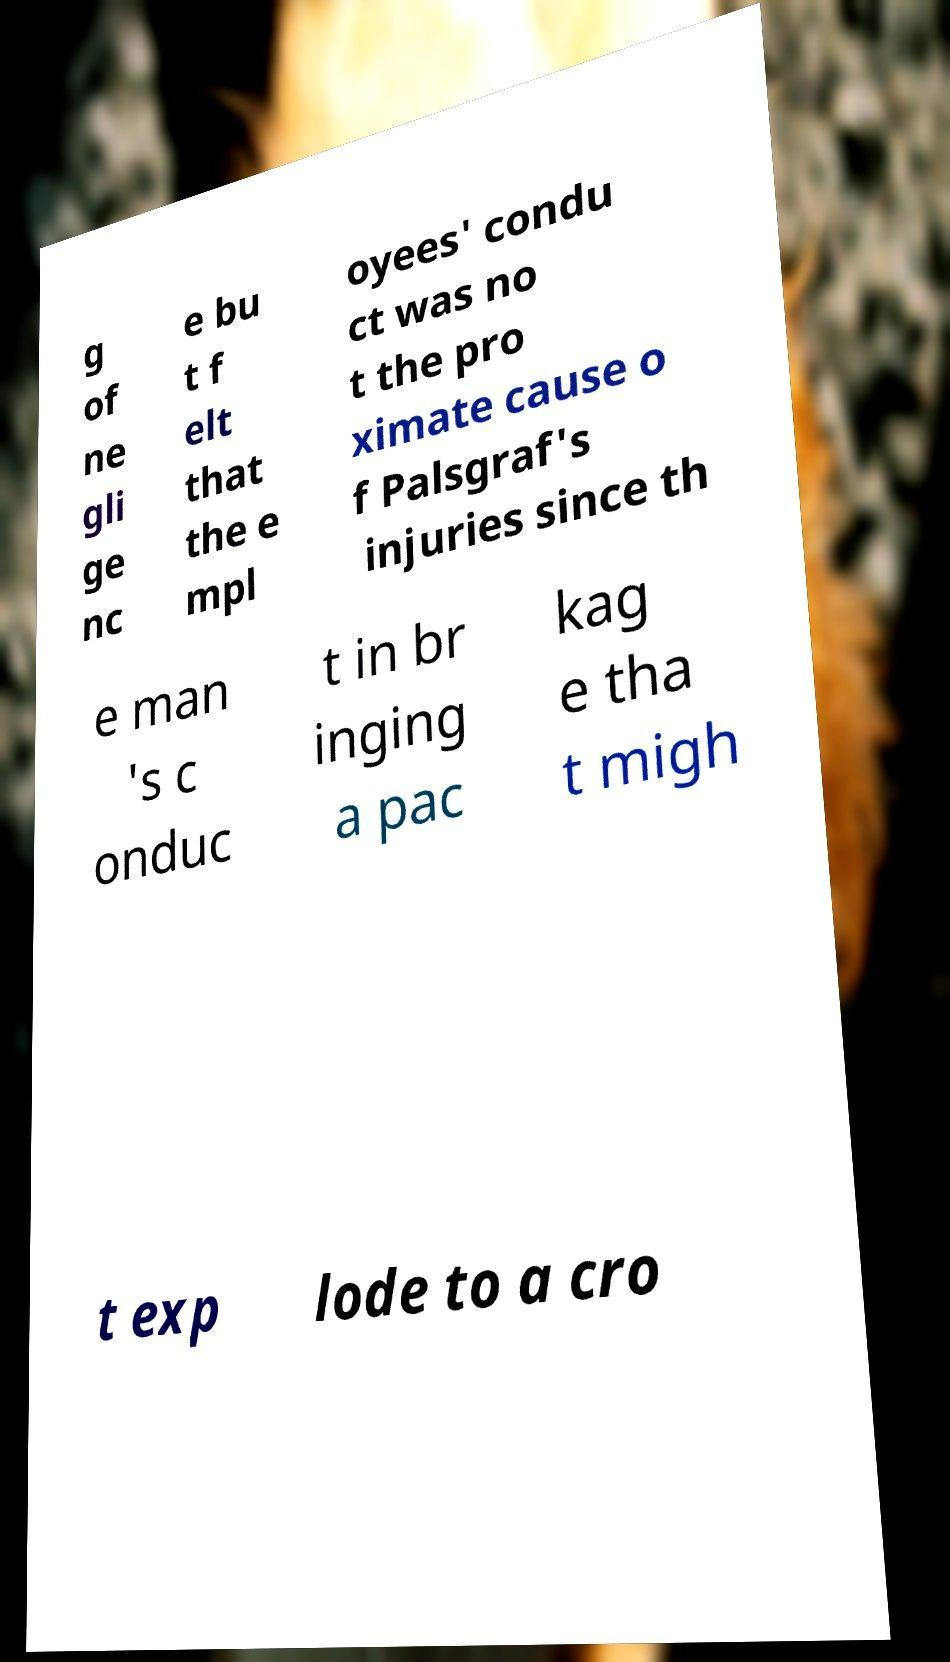Can you accurately transcribe the text from the provided image for me? g of ne gli ge nc e bu t f elt that the e mpl oyees' condu ct was no t the pro ximate cause o f Palsgraf's injuries since th e man 's c onduc t in br inging a pac kag e tha t migh t exp lode to a cro 